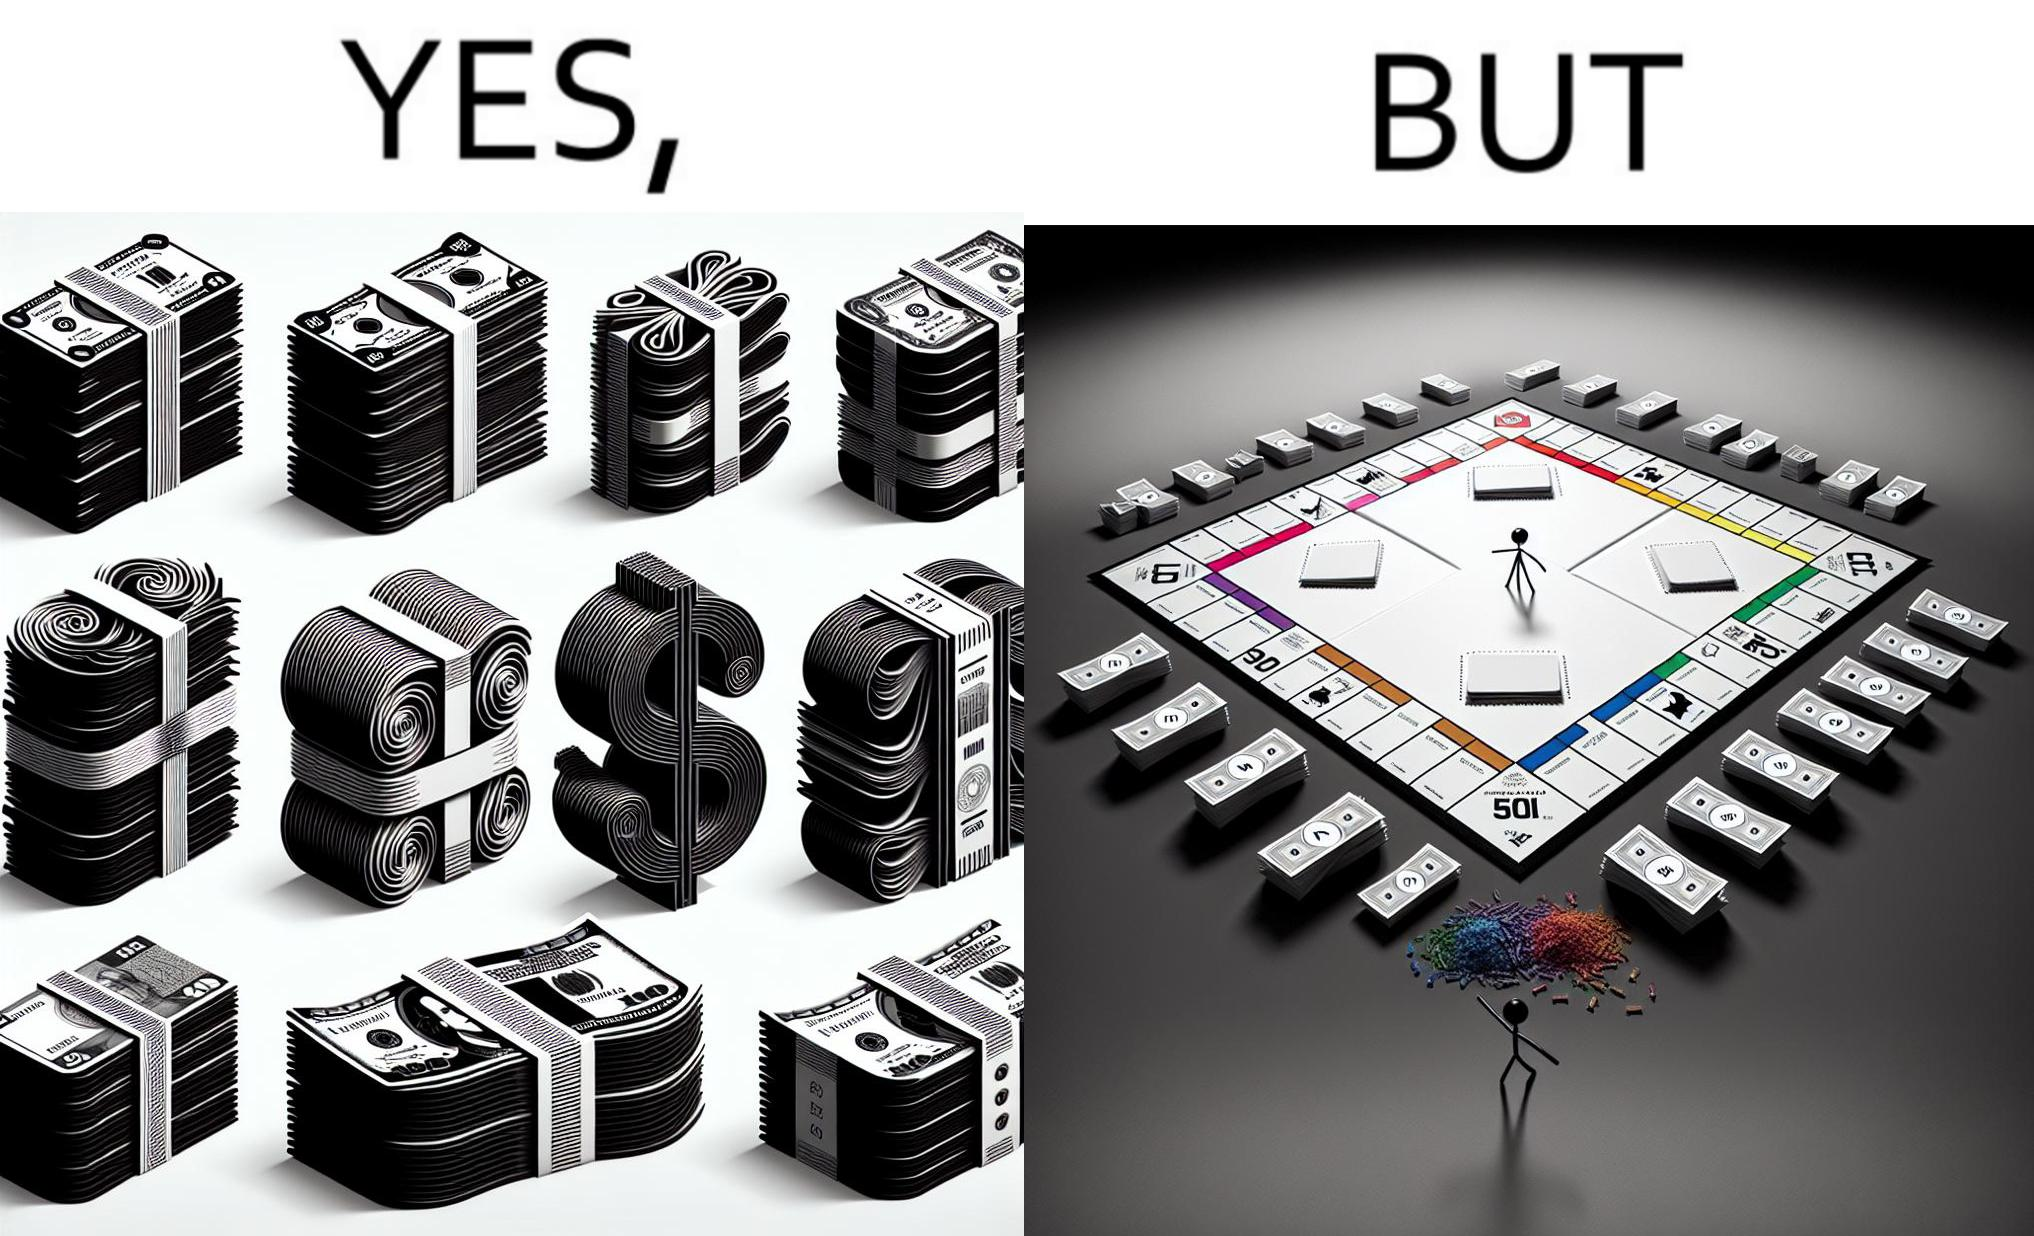What makes this image funny or satirical? The image is ironic, because there are many different color currency notes' bundles but they are just as a currency in the game of monopoly and they have no real value 